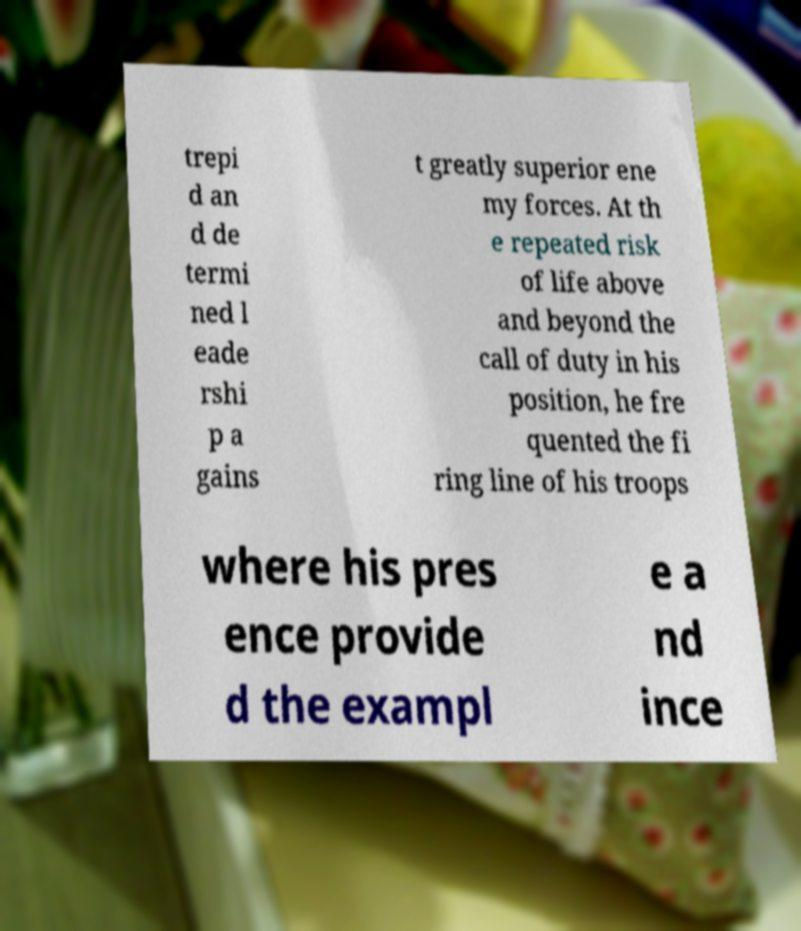Could you extract and type out the text from this image? trepi d an d de termi ned l eade rshi p a gains t greatly superior ene my forces. At th e repeated risk of life above and beyond the call of duty in his position, he fre quented the fi ring line of his troops where his pres ence provide d the exampl e a nd ince 